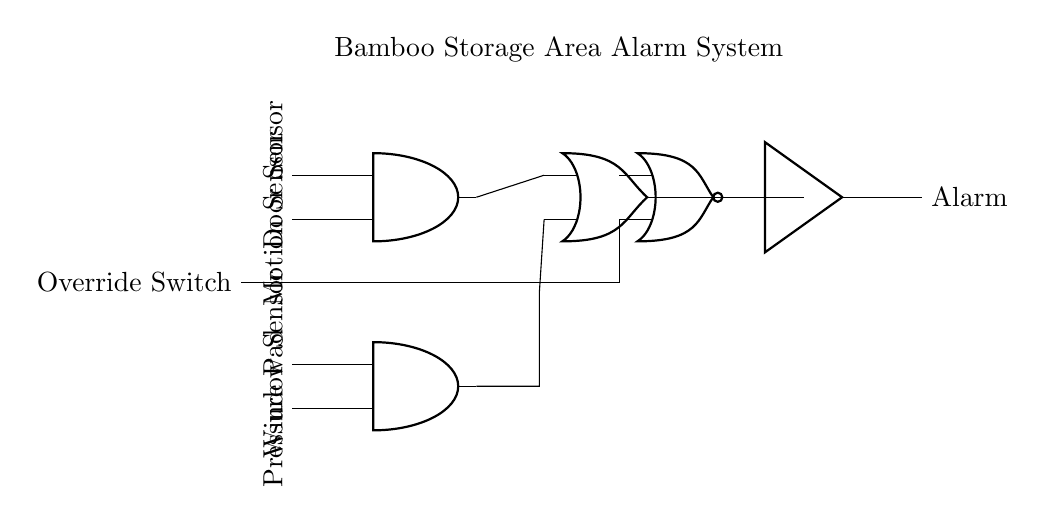What are the types of sensors used in the alarm system? The alarm system utilizes two types of sensors: a door sensor and a motion sensor, which are connected to the first AND gate. This indicates that both sensors must be triggered to activate the output of the first AND gate.
Answer: Door sensor and motion sensor How many AND gates are present in the circuit? There are two AND gates depicted in the circuit diagram, as shown in the connections and labels. The first AND gate receives input from the door and motion sensors, while the second AND gate gets input from the window sensor and pressure pad.
Answer: Two What is the output of the first AND gate when both inputs are active? The output of the first AND gate is high (active), indicating that the alarm system has received positive input signals from both the door sensor and motion sensor. In an AND gate, this occurs only when all inputs are true (active).
Answer: High What does the NOR gate control in the diagram? The NOR gate in the diagram controls the output based on the combination of other gates and the override switch, allowing the system to disable the alarm if the override switch is activated. This is characteristic of a NOR gate, which produces a low output when any input is high.
Answer: Alarm activation If the pressure pad is activated and the window sensor is not, what is the output of the second AND gate? The output of the second AND gate would be low (inactive) since one of its inputs (the window sensor) is not active. For an AND gate to produce a high output, all its inputs must be active.
Answer: Low What is the function of the buffer in the circuit? The buffer's function is to isolate, strengthen, and maintain the output signal of the NOR gate. It ensures that the alarm system produces a consistent output even if the input signal from the NOR gate fluctuates.
Answer: Signal strengthening 